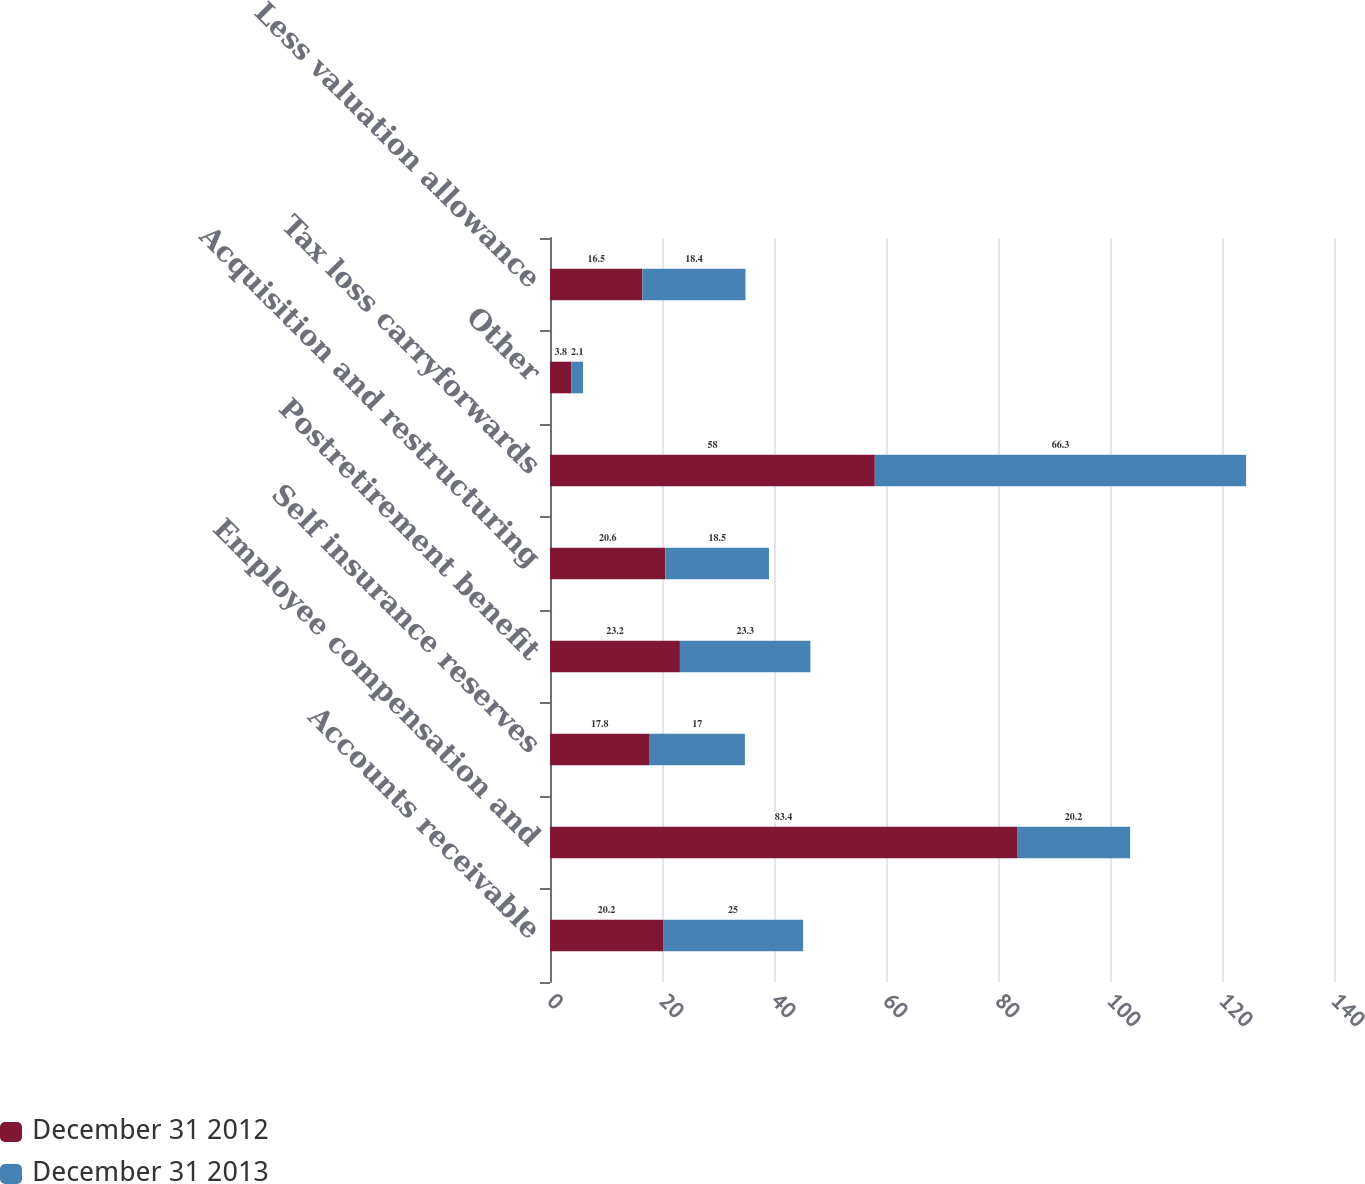Convert chart. <chart><loc_0><loc_0><loc_500><loc_500><stacked_bar_chart><ecel><fcel>Accounts receivable<fcel>Employee compensation and<fcel>Self insurance reserves<fcel>Postretirement benefit<fcel>Acquisition and restructuring<fcel>Tax loss carryforwards<fcel>Other<fcel>Less valuation allowance<nl><fcel>December 31 2012<fcel>20.2<fcel>83.4<fcel>17.8<fcel>23.2<fcel>20.6<fcel>58<fcel>3.8<fcel>16.5<nl><fcel>December 31 2013<fcel>25<fcel>20.2<fcel>17<fcel>23.3<fcel>18.5<fcel>66.3<fcel>2.1<fcel>18.4<nl></chart> 